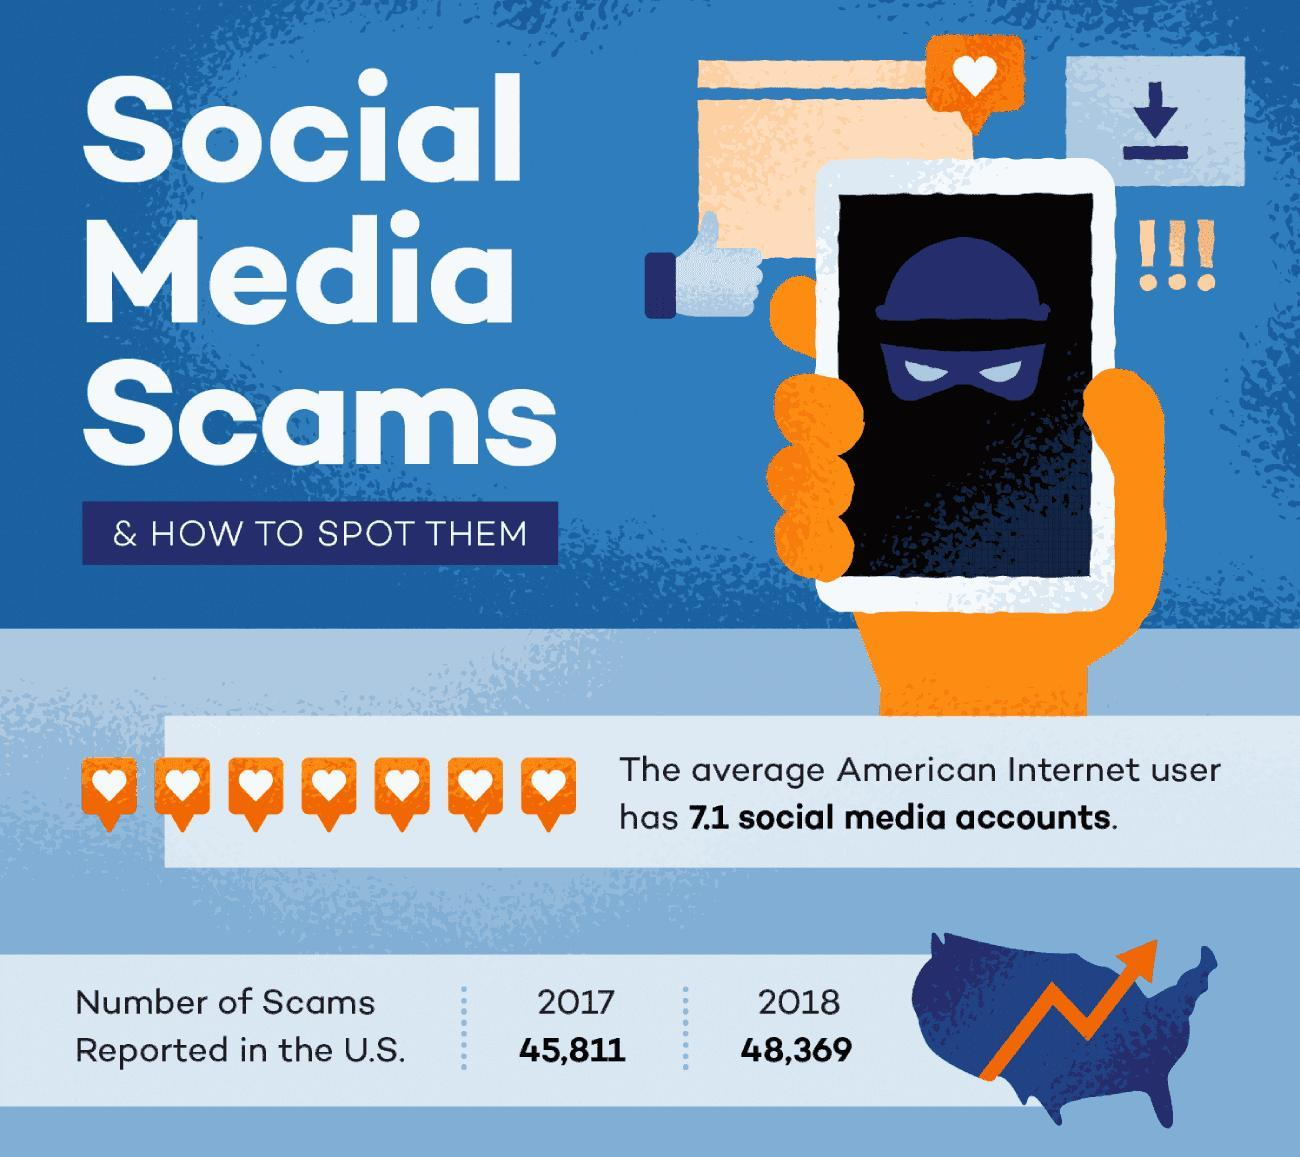What is the number of scams reported in the U.S. in 2018?
Answer the question with a short phrase. 48,369 What is the number of scams reported in the U.S. in 2017? 45,811 